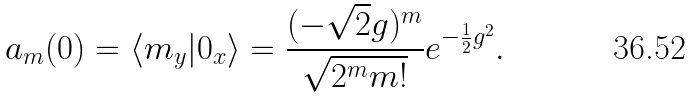Convert formula to latex. <formula><loc_0><loc_0><loc_500><loc_500>a _ { m } ( 0 ) = \langle m _ { y } | 0 _ { x } \rangle = \frac { ( - \sqrt { 2 } g ) ^ { m } } { \sqrt { 2 ^ { m } m ! } } e ^ { - \frac { 1 } { 2 } g ^ { 2 } } .</formula> 